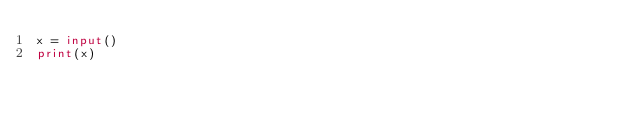<code> <loc_0><loc_0><loc_500><loc_500><_Python_>x = input()
print(x)

</code> 